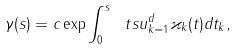<formula> <loc_0><loc_0><loc_500><loc_500>\gamma ( s ) = c \exp \int _ { 0 } ^ { s } \ t s u _ { k = 1 } ^ { d } \varkappa _ { k } ( t ) d t _ { k } ,</formula> 